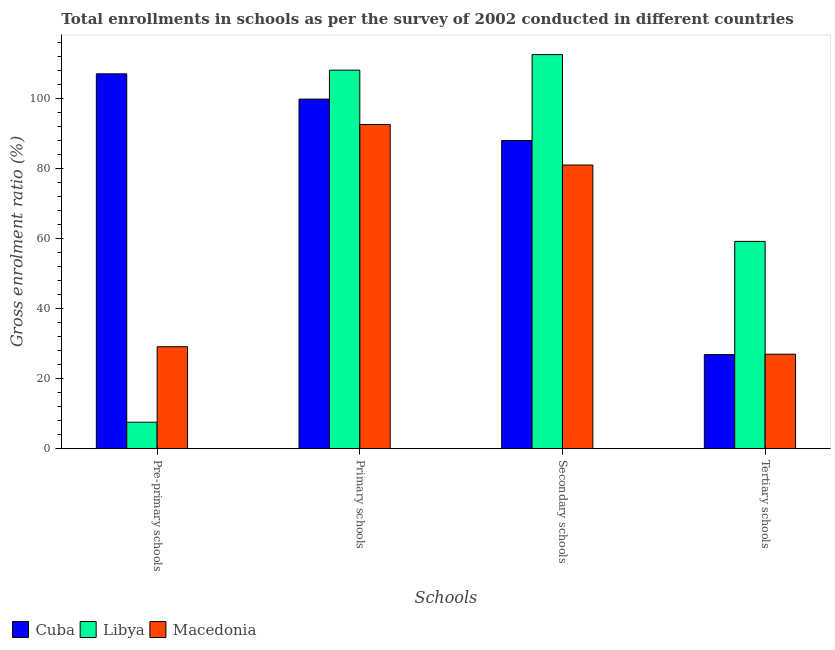How many different coloured bars are there?
Offer a very short reply. 3. Are the number of bars per tick equal to the number of legend labels?
Give a very brief answer. Yes. How many bars are there on the 3rd tick from the left?
Keep it short and to the point. 3. What is the label of the 3rd group of bars from the left?
Offer a very short reply. Secondary schools. What is the gross enrolment ratio in secondary schools in Libya?
Make the answer very short. 112.62. Across all countries, what is the maximum gross enrolment ratio in secondary schools?
Give a very brief answer. 112.62. Across all countries, what is the minimum gross enrolment ratio in secondary schools?
Your response must be concise. 81.06. In which country was the gross enrolment ratio in secondary schools maximum?
Your response must be concise. Libya. In which country was the gross enrolment ratio in secondary schools minimum?
Provide a succinct answer. Macedonia. What is the total gross enrolment ratio in primary schools in the graph?
Offer a very short reply. 300.7. What is the difference between the gross enrolment ratio in secondary schools in Macedonia and that in Cuba?
Provide a succinct answer. -7. What is the difference between the gross enrolment ratio in primary schools in Macedonia and the gross enrolment ratio in tertiary schools in Libya?
Your answer should be very brief. 33.41. What is the average gross enrolment ratio in primary schools per country?
Provide a short and direct response. 100.23. What is the difference between the gross enrolment ratio in tertiary schools and gross enrolment ratio in secondary schools in Macedonia?
Offer a very short reply. -54.07. In how many countries, is the gross enrolment ratio in tertiary schools greater than 24 %?
Your response must be concise. 3. What is the ratio of the gross enrolment ratio in tertiary schools in Libya to that in Cuba?
Make the answer very short. 2.2. Is the gross enrolment ratio in secondary schools in Cuba less than that in Macedonia?
Offer a very short reply. No. What is the difference between the highest and the second highest gross enrolment ratio in primary schools?
Provide a succinct answer. 8.27. What is the difference between the highest and the lowest gross enrolment ratio in secondary schools?
Offer a very short reply. 31.56. In how many countries, is the gross enrolment ratio in secondary schools greater than the average gross enrolment ratio in secondary schools taken over all countries?
Offer a very short reply. 1. Is the sum of the gross enrolment ratio in secondary schools in Libya and Macedonia greater than the maximum gross enrolment ratio in pre-primary schools across all countries?
Your answer should be very brief. Yes. Is it the case that in every country, the sum of the gross enrolment ratio in primary schools and gross enrolment ratio in tertiary schools is greater than the sum of gross enrolment ratio in pre-primary schools and gross enrolment ratio in secondary schools?
Keep it short and to the point. Yes. What does the 3rd bar from the left in Primary schools represents?
Provide a short and direct response. Macedonia. What does the 2nd bar from the right in Pre-primary schools represents?
Give a very brief answer. Libya. Is it the case that in every country, the sum of the gross enrolment ratio in pre-primary schools and gross enrolment ratio in primary schools is greater than the gross enrolment ratio in secondary schools?
Offer a terse response. Yes. Where does the legend appear in the graph?
Ensure brevity in your answer.  Bottom left. How many legend labels are there?
Offer a terse response. 3. How are the legend labels stacked?
Your answer should be very brief. Horizontal. What is the title of the graph?
Give a very brief answer. Total enrollments in schools as per the survey of 2002 conducted in different countries. Does "Turkmenistan" appear as one of the legend labels in the graph?
Your answer should be very brief. No. What is the label or title of the X-axis?
Offer a terse response. Schools. What is the Gross enrolment ratio (%) in Cuba in Pre-primary schools?
Give a very brief answer. 107.12. What is the Gross enrolment ratio (%) in Libya in Pre-primary schools?
Your answer should be very brief. 7.56. What is the Gross enrolment ratio (%) of Macedonia in Pre-primary schools?
Your response must be concise. 29.13. What is the Gross enrolment ratio (%) in Cuba in Primary schools?
Offer a very short reply. 99.89. What is the Gross enrolment ratio (%) of Libya in Primary schools?
Make the answer very short. 108.17. What is the Gross enrolment ratio (%) in Macedonia in Primary schools?
Provide a short and direct response. 92.64. What is the Gross enrolment ratio (%) in Cuba in Secondary schools?
Your answer should be compact. 88.07. What is the Gross enrolment ratio (%) of Libya in Secondary schools?
Give a very brief answer. 112.62. What is the Gross enrolment ratio (%) of Macedonia in Secondary schools?
Ensure brevity in your answer.  81.06. What is the Gross enrolment ratio (%) in Cuba in Tertiary schools?
Offer a very short reply. 26.88. What is the Gross enrolment ratio (%) of Libya in Tertiary schools?
Your response must be concise. 59.24. What is the Gross enrolment ratio (%) in Macedonia in Tertiary schools?
Provide a succinct answer. 26.99. Across all Schools, what is the maximum Gross enrolment ratio (%) in Cuba?
Offer a very short reply. 107.12. Across all Schools, what is the maximum Gross enrolment ratio (%) in Libya?
Give a very brief answer. 112.62. Across all Schools, what is the maximum Gross enrolment ratio (%) of Macedonia?
Offer a terse response. 92.64. Across all Schools, what is the minimum Gross enrolment ratio (%) in Cuba?
Offer a terse response. 26.88. Across all Schools, what is the minimum Gross enrolment ratio (%) in Libya?
Your answer should be compact. 7.56. Across all Schools, what is the minimum Gross enrolment ratio (%) of Macedonia?
Provide a short and direct response. 26.99. What is the total Gross enrolment ratio (%) in Cuba in the graph?
Your response must be concise. 321.96. What is the total Gross enrolment ratio (%) of Libya in the graph?
Give a very brief answer. 287.59. What is the total Gross enrolment ratio (%) in Macedonia in the graph?
Make the answer very short. 229.83. What is the difference between the Gross enrolment ratio (%) of Cuba in Pre-primary schools and that in Primary schools?
Offer a very short reply. 7.23. What is the difference between the Gross enrolment ratio (%) of Libya in Pre-primary schools and that in Primary schools?
Your response must be concise. -100.61. What is the difference between the Gross enrolment ratio (%) in Macedonia in Pre-primary schools and that in Primary schools?
Your response must be concise. -63.51. What is the difference between the Gross enrolment ratio (%) in Cuba in Pre-primary schools and that in Secondary schools?
Offer a terse response. 19.05. What is the difference between the Gross enrolment ratio (%) in Libya in Pre-primary schools and that in Secondary schools?
Your answer should be compact. -105.06. What is the difference between the Gross enrolment ratio (%) of Macedonia in Pre-primary schools and that in Secondary schools?
Your response must be concise. -51.93. What is the difference between the Gross enrolment ratio (%) of Cuba in Pre-primary schools and that in Tertiary schools?
Provide a succinct answer. 80.24. What is the difference between the Gross enrolment ratio (%) of Libya in Pre-primary schools and that in Tertiary schools?
Offer a very short reply. -51.67. What is the difference between the Gross enrolment ratio (%) in Macedonia in Pre-primary schools and that in Tertiary schools?
Your answer should be compact. 2.14. What is the difference between the Gross enrolment ratio (%) in Cuba in Primary schools and that in Secondary schools?
Keep it short and to the point. 11.83. What is the difference between the Gross enrolment ratio (%) of Libya in Primary schools and that in Secondary schools?
Keep it short and to the point. -4.46. What is the difference between the Gross enrolment ratio (%) in Macedonia in Primary schools and that in Secondary schools?
Make the answer very short. 11.58. What is the difference between the Gross enrolment ratio (%) in Cuba in Primary schools and that in Tertiary schools?
Provide a short and direct response. 73.01. What is the difference between the Gross enrolment ratio (%) in Libya in Primary schools and that in Tertiary schools?
Offer a terse response. 48.93. What is the difference between the Gross enrolment ratio (%) of Macedonia in Primary schools and that in Tertiary schools?
Your response must be concise. 65.65. What is the difference between the Gross enrolment ratio (%) of Cuba in Secondary schools and that in Tertiary schools?
Make the answer very short. 61.19. What is the difference between the Gross enrolment ratio (%) of Libya in Secondary schools and that in Tertiary schools?
Provide a short and direct response. 53.39. What is the difference between the Gross enrolment ratio (%) of Macedonia in Secondary schools and that in Tertiary schools?
Offer a very short reply. 54.07. What is the difference between the Gross enrolment ratio (%) in Cuba in Pre-primary schools and the Gross enrolment ratio (%) in Libya in Primary schools?
Provide a short and direct response. -1.05. What is the difference between the Gross enrolment ratio (%) in Cuba in Pre-primary schools and the Gross enrolment ratio (%) in Macedonia in Primary schools?
Make the answer very short. 14.48. What is the difference between the Gross enrolment ratio (%) of Libya in Pre-primary schools and the Gross enrolment ratio (%) of Macedonia in Primary schools?
Offer a very short reply. -85.08. What is the difference between the Gross enrolment ratio (%) of Cuba in Pre-primary schools and the Gross enrolment ratio (%) of Libya in Secondary schools?
Offer a terse response. -5.5. What is the difference between the Gross enrolment ratio (%) of Cuba in Pre-primary schools and the Gross enrolment ratio (%) of Macedonia in Secondary schools?
Your answer should be compact. 26.06. What is the difference between the Gross enrolment ratio (%) in Libya in Pre-primary schools and the Gross enrolment ratio (%) in Macedonia in Secondary schools?
Provide a short and direct response. -73.5. What is the difference between the Gross enrolment ratio (%) of Cuba in Pre-primary schools and the Gross enrolment ratio (%) of Libya in Tertiary schools?
Give a very brief answer. 47.88. What is the difference between the Gross enrolment ratio (%) of Cuba in Pre-primary schools and the Gross enrolment ratio (%) of Macedonia in Tertiary schools?
Your answer should be compact. 80.13. What is the difference between the Gross enrolment ratio (%) of Libya in Pre-primary schools and the Gross enrolment ratio (%) of Macedonia in Tertiary schools?
Make the answer very short. -19.43. What is the difference between the Gross enrolment ratio (%) in Cuba in Primary schools and the Gross enrolment ratio (%) in Libya in Secondary schools?
Provide a short and direct response. -12.73. What is the difference between the Gross enrolment ratio (%) in Cuba in Primary schools and the Gross enrolment ratio (%) in Macedonia in Secondary schools?
Offer a very short reply. 18.83. What is the difference between the Gross enrolment ratio (%) in Libya in Primary schools and the Gross enrolment ratio (%) in Macedonia in Secondary schools?
Provide a succinct answer. 27.11. What is the difference between the Gross enrolment ratio (%) in Cuba in Primary schools and the Gross enrolment ratio (%) in Libya in Tertiary schools?
Provide a short and direct response. 40.66. What is the difference between the Gross enrolment ratio (%) of Cuba in Primary schools and the Gross enrolment ratio (%) of Macedonia in Tertiary schools?
Ensure brevity in your answer.  72.9. What is the difference between the Gross enrolment ratio (%) in Libya in Primary schools and the Gross enrolment ratio (%) in Macedonia in Tertiary schools?
Offer a terse response. 81.17. What is the difference between the Gross enrolment ratio (%) in Cuba in Secondary schools and the Gross enrolment ratio (%) in Libya in Tertiary schools?
Provide a succinct answer. 28.83. What is the difference between the Gross enrolment ratio (%) in Cuba in Secondary schools and the Gross enrolment ratio (%) in Macedonia in Tertiary schools?
Ensure brevity in your answer.  61.07. What is the difference between the Gross enrolment ratio (%) in Libya in Secondary schools and the Gross enrolment ratio (%) in Macedonia in Tertiary schools?
Your response must be concise. 85.63. What is the average Gross enrolment ratio (%) of Cuba per Schools?
Provide a succinct answer. 80.49. What is the average Gross enrolment ratio (%) of Libya per Schools?
Your answer should be very brief. 71.9. What is the average Gross enrolment ratio (%) of Macedonia per Schools?
Provide a succinct answer. 57.46. What is the difference between the Gross enrolment ratio (%) in Cuba and Gross enrolment ratio (%) in Libya in Pre-primary schools?
Keep it short and to the point. 99.56. What is the difference between the Gross enrolment ratio (%) in Cuba and Gross enrolment ratio (%) in Macedonia in Pre-primary schools?
Give a very brief answer. 77.99. What is the difference between the Gross enrolment ratio (%) of Libya and Gross enrolment ratio (%) of Macedonia in Pre-primary schools?
Provide a succinct answer. -21.57. What is the difference between the Gross enrolment ratio (%) in Cuba and Gross enrolment ratio (%) in Libya in Primary schools?
Ensure brevity in your answer.  -8.27. What is the difference between the Gross enrolment ratio (%) of Cuba and Gross enrolment ratio (%) of Macedonia in Primary schools?
Your response must be concise. 7.25. What is the difference between the Gross enrolment ratio (%) of Libya and Gross enrolment ratio (%) of Macedonia in Primary schools?
Make the answer very short. 15.52. What is the difference between the Gross enrolment ratio (%) of Cuba and Gross enrolment ratio (%) of Libya in Secondary schools?
Make the answer very short. -24.56. What is the difference between the Gross enrolment ratio (%) of Cuba and Gross enrolment ratio (%) of Macedonia in Secondary schools?
Make the answer very short. 7. What is the difference between the Gross enrolment ratio (%) of Libya and Gross enrolment ratio (%) of Macedonia in Secondary schools?
Keep it short and to the point. 31.56. What is the difference between the Gross enrolment ratio (%) in Cuba and Gross enrolment ratio (%) in Libya in Tertiary schools?
Give a very brief answer. -32.36. What is the difference between the Gross enrolment ratio (%) in Cuba and Gross enrolment ratio (%) in Macedonia in Tertiary schools?
Ensure brevity in your answer.  -0.11. What is the difference between the Gross enrolment ratio (%) of Libya and Gross enrolment ratio (%) of Macedonia in Tertiary schools?
Provide a succinct answer. 32.24. What is the ratio of the Gross enrolment ratio (%) in Cuba in Pre-primary schools to that in Primary schools?
Offer a very short reply. 1.07. What is the ratio of the Gross enrolment ratio (%) in Libya in Pre-primary schools to that in Primary schools?
Your response must be concise. 0.07. What is the ratio of the Gross enrolment ratio (%) of Macedonia in Pre-primary schools to that in Primary schools?
Offer a terse response. 0.31. What is the ratio of the Gross enrolment ratio (%) of Cuba in Pre-primary schools to that in Secondary schools?
Your response must be concise. 1.22. What is the ratio of the Gross enrolment ratio (%) in Libya in Pre-primary schools to that in Secondary schools?
Your answer should be very brief. 0.07. What is the ratio of the Gross enrolment ratio (%) of Macedonia in Pre-primary schools to that in Secondary schools?
Offer a very short reply. 0.36. What is the ratio of the Gross enrolment ratio (%) of Cuba in Pre-primary schools to that in Tertiary schools?
Provide a short and direct response. 3.99. What is the ratio of the Gross enrolment ratio (%) in Libya in Pre-primary schools to that in Tertiary schools?
Make the answer very short. 0.13. What is the ratio of the Gross enrolment ratio (%) in Macedonia in Pre-primary schools to that in Tertiary schools?
Your answer should be very brief. 1.08. What is the ratio of the Gross enrolment ratio (%) of Cuba in Primary schools to that in Secondary schools?
Your answer should be very brief. 1.13. What is the ratio of the Gross enrolment ratio (%) of Libya in Primary schools to that in Secondary schools?
Offer a very short reply. 0.96. What is the ratio of the Gross enrolment ratio (%) of Cuba in Primary schools to that in Tertiary schools?
Keep it short and to the point. 3.72. What is the ratio of the Gross enrolment ratio (%) in Libya in Primary schools to that in Tertiary schools?
Keep it short and to the point. 1.83. What is the ratio of the Gross enrolment ratio (%) in Macedonia in Primary schools to that in Tertiary schools?
Your answer should be compact. 3.43. What is the ratio of the Gross enrolment ratio (%) of Cuba in Secondary schools to that in Tertiary schools?
Make the answer very short. 3.28. What is the ratio of the Gross enrolment ratio (%) in Libya in Secondary schools to that in Tertiary schools?
Your response must be concise. 1.9. What is the ratio of the Gross enrolment ratio (%) in Macedonia in Secondary schools to that in Tertiary schools?
Ensure brevity in your answer.  3. What is the difference between the highest and the second highest Gross enrolment ratio (%) in Cuba?
Ensure brevity in your answer.  7.23. What is the difference between the highest and the second highest Gross enrolment ratio (%) in Libya?
Provide a short and direct response. 4.46. What is the difference between the highest and the second highest Gross enrolment ratio (%) of Macedonia?
Offer a very short reply. 11.58. What is the difference between the highest and the lowest Gross enrolment ratio (%) in Cuba?
Your response must be concise. 80.24. What is the difference between the highest and the lowest Gross enrolment ratio (%) in Libya?
Provide a short and direct response. 105.06. What is the difference between the highest and the lowest Gross enrolment ratio (%) in Macedonia?
Provide a short and direct response. 65.65. 